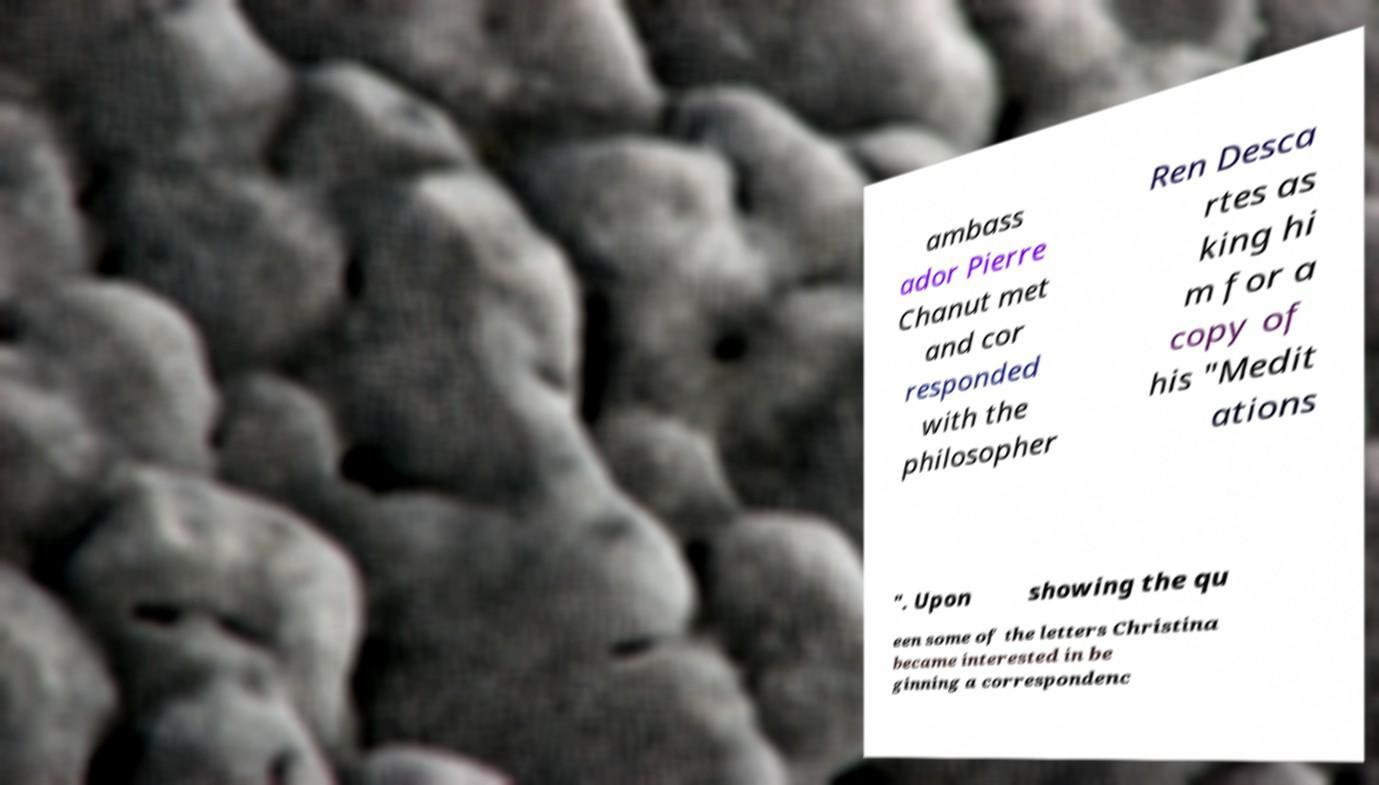Please read and relay the text visible in this image. What does it say? ambass ador Pierre Chanut met and cor responded with the philosopher Ren Desca rtes as king hi m for a copy of his "Medit ations ". Upon showing the qu een some of the letters Christina became interested in be ginning a correspondenc 